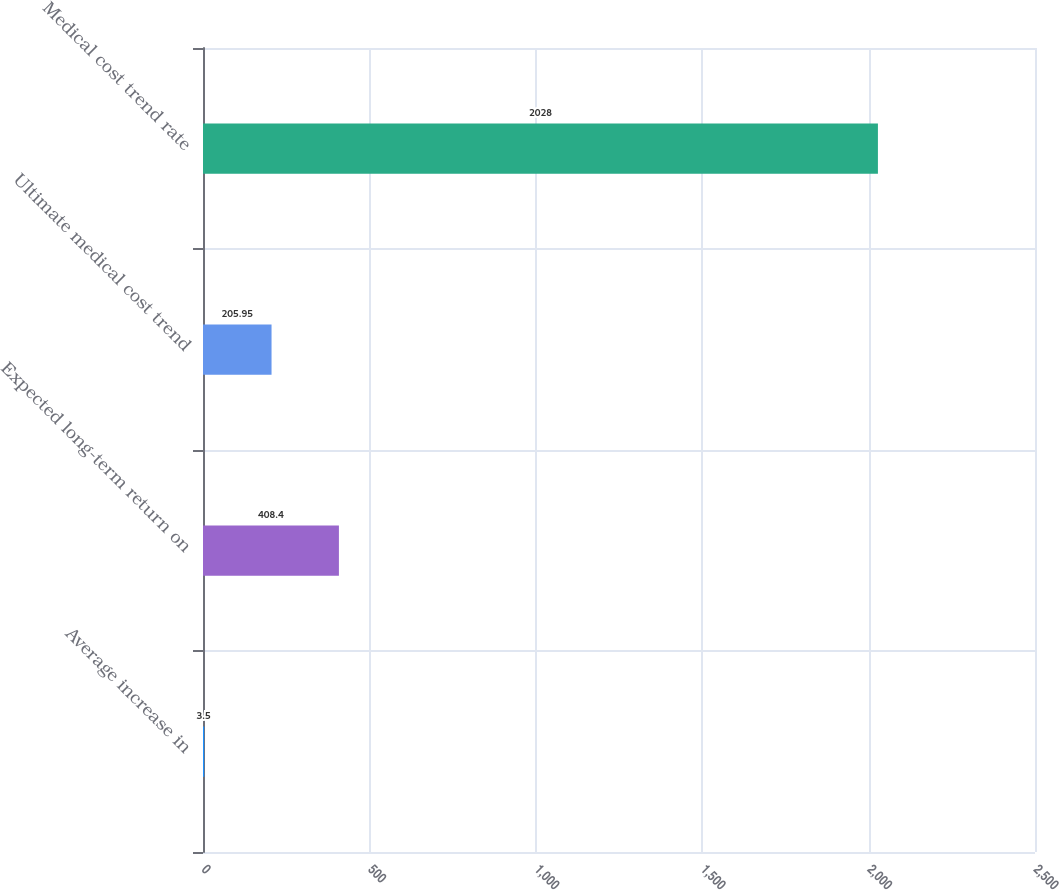Convert chart to OTSL. <chart><loc_0><loc_0><loc_500><loc_500><bar_chart><fcel>Average increase in<fcel>Expected long-term return on<fcel>Ultimate medical cost trend<fcel>Medical cost trend rate<nl><fcel>3.5<fcel>408.4<fcel>205.95<fcel>2028<nl></chart> 